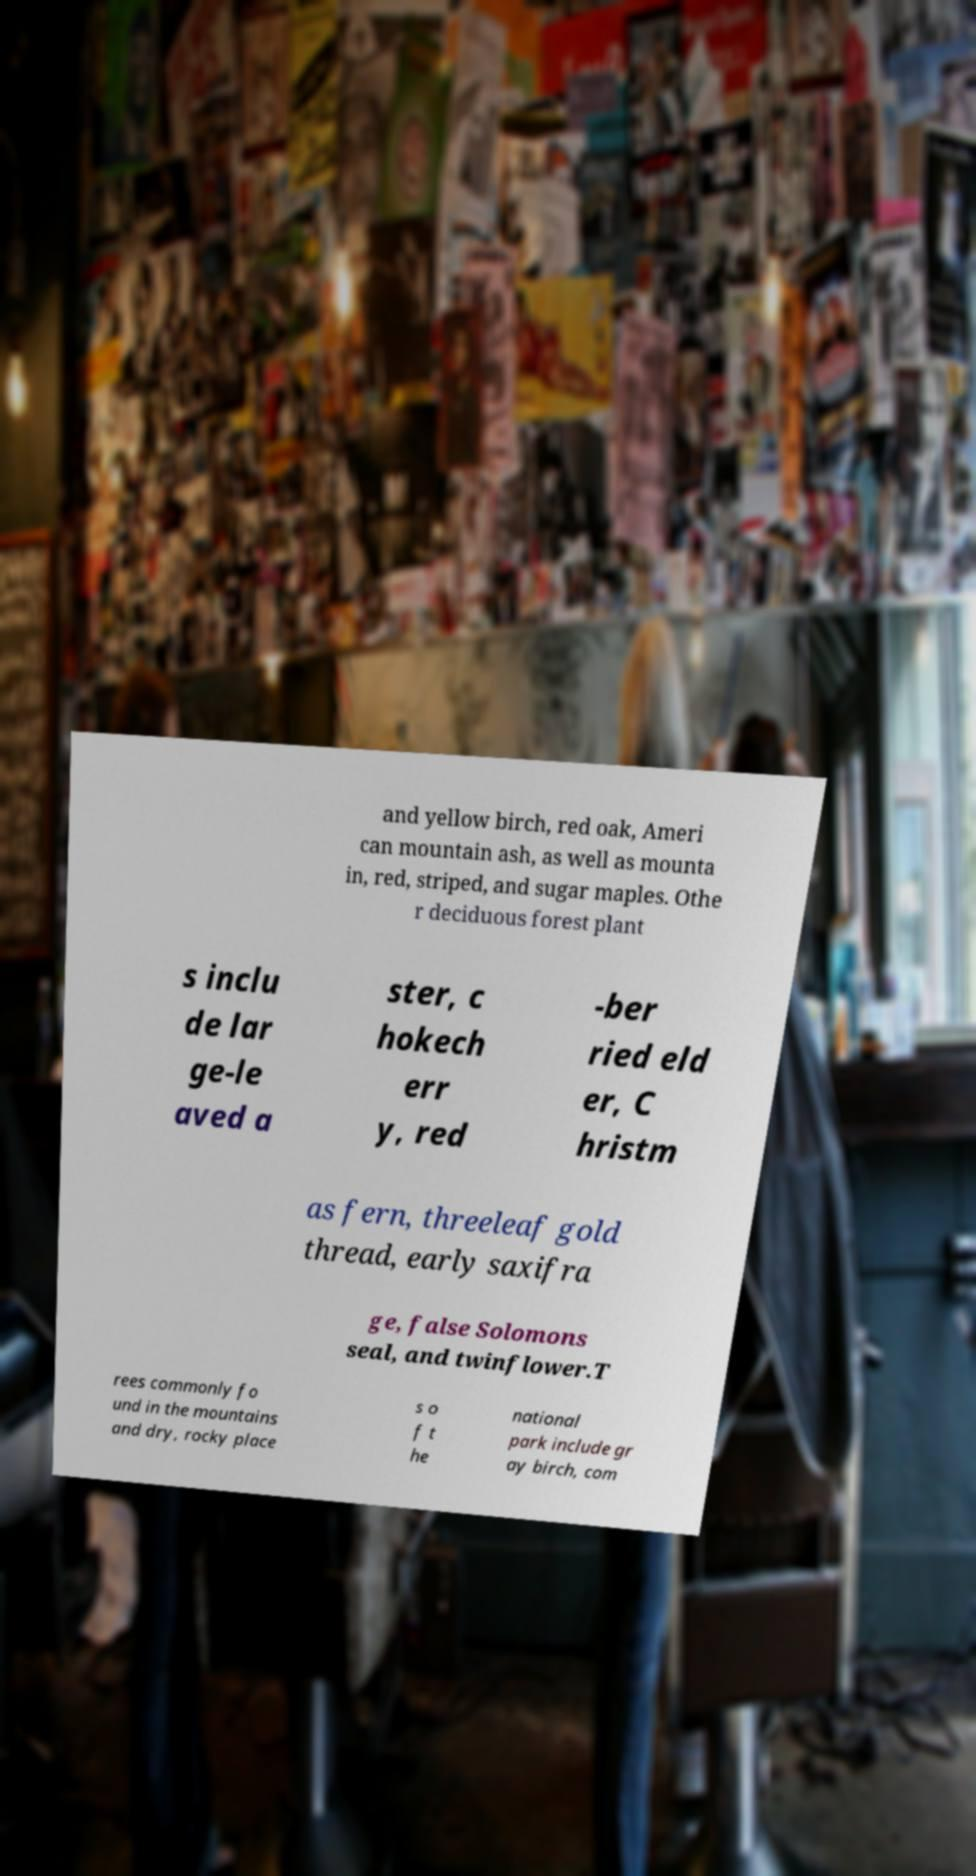What messages or text are displayed in this image? I need them in a readable, typed format. and yellow birch, red oak, Ameri can mountain ash, as well as mounta in, red, striped, and sugar maples. Othe r deciduous forest plant s inclu de lar ge-le aved a ster, c hokech err y, red -ber ried eld er, C hristm as fern, threeleaf gold thread, early saxifra ge, false Solomons seal, and twinflower.T rees commonly fo und in the mountains and dry, rocky place s o f t he national park include gr ay birch, com 